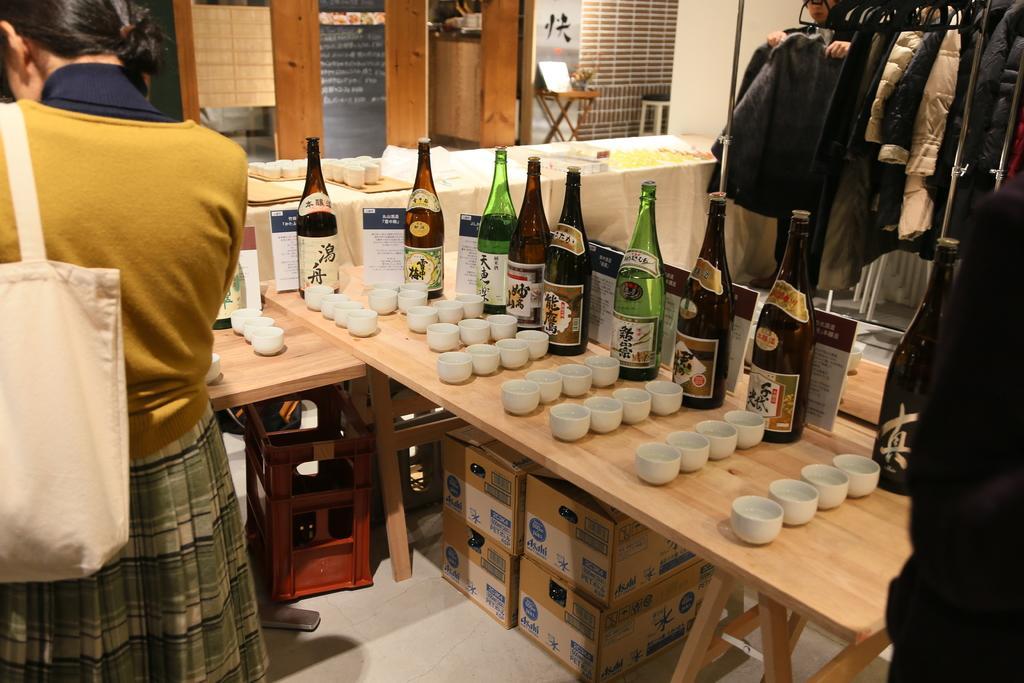Can you describe this image briefly? In this image I see a woman who is carrying a bag and on the table I see lot of bottles and cups. Under the table I see few boxes and over here I see the clothes. 